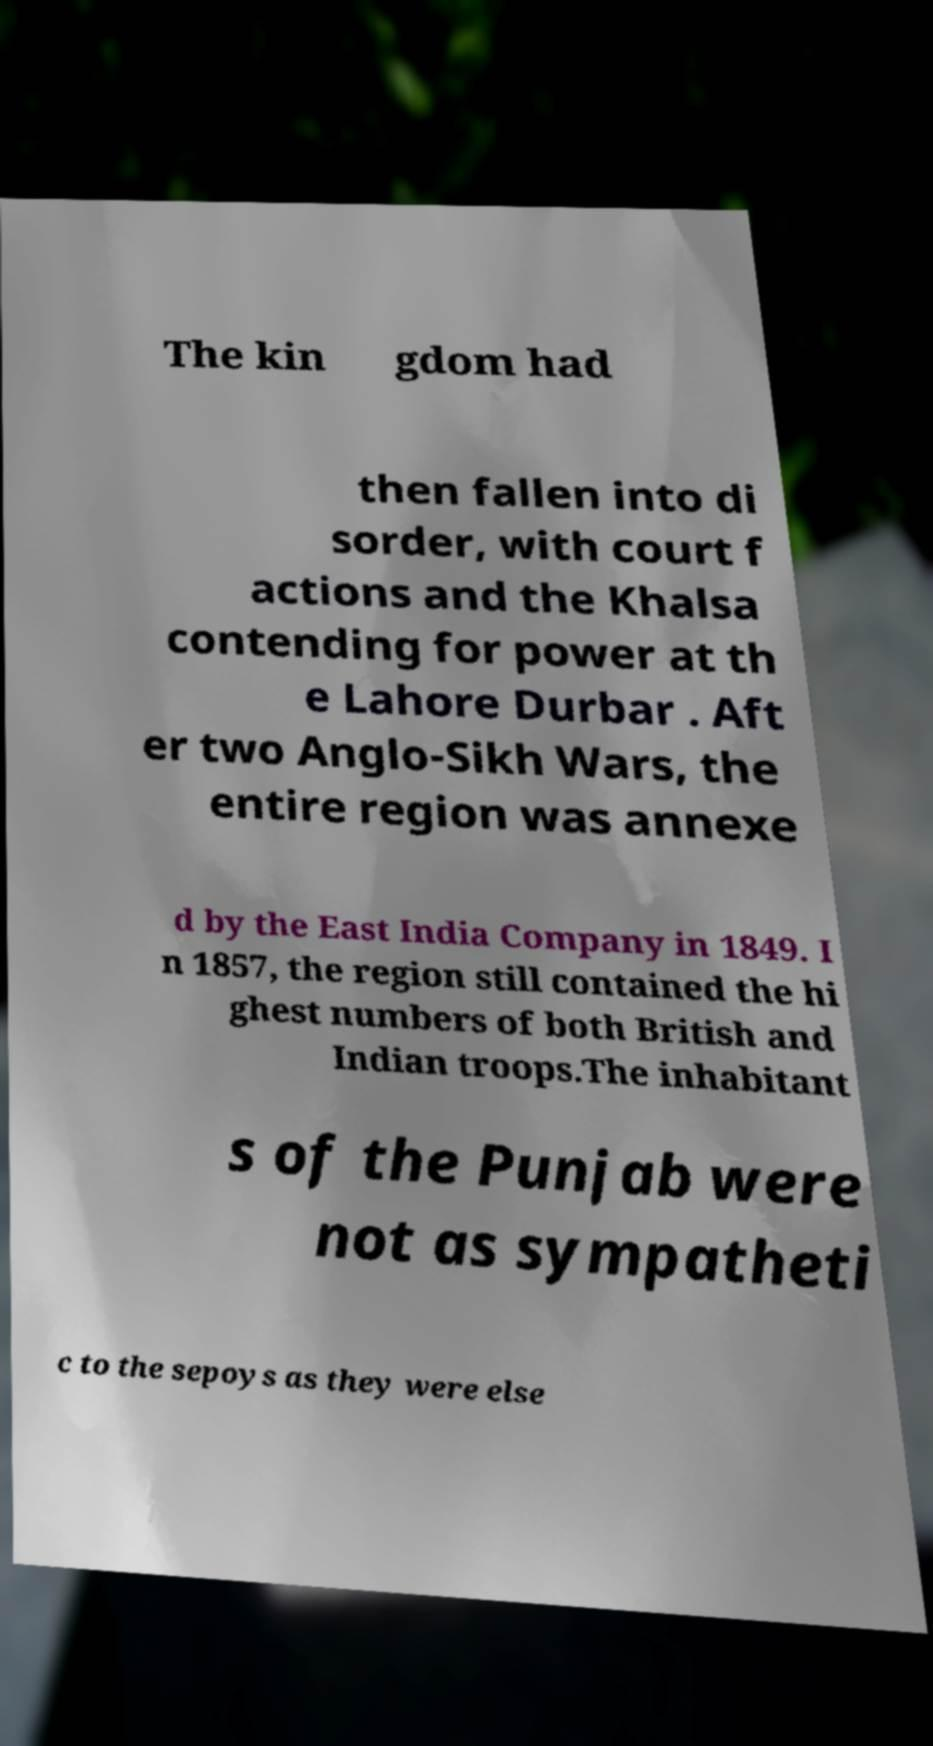What messages or text are displayed in this image? I need them in a readable, typed format. The kin gdom had then fallen into di sorder, with court f actions and the Khalsa contending for power at th e Lahore Durbar . Aft er two Anglo-Sikh Wars, the entire region was annexe d by the East India Company in 1849. I n 1857, the region still contained the hi ghest numbers of both British and Indian troops.The inhabitant s of the Punjab were not as sympatheti c to the sepoys as they were else 